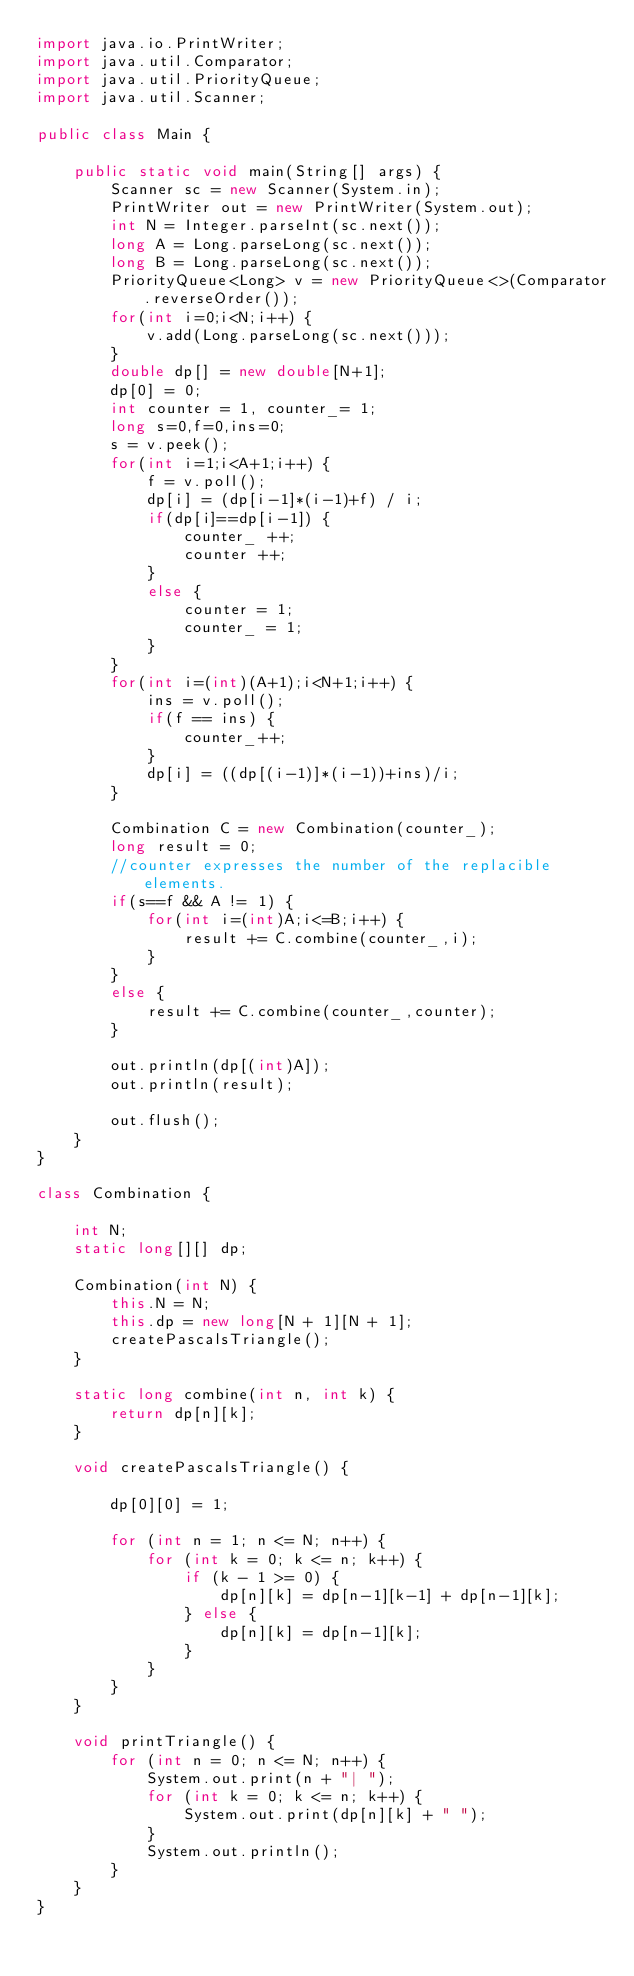<code> <loc_0><loc_0><loc_500><loc_500><_Java_>import java.io.PrintWriter;
import java.util.Comparator;
import java.util.PriorityQueue;
import java.util.Scanner;

public class Main {

	public static void main(String[] args) {
		Scanner sc = new Scanner(System.in);
		PrintWriter out = new PrintWriter(System.out);
		int N = Integer.parseInt(sc.next());
		long A = Long.parseLong(sc.next());
		long B = Long.parseLong(sc.next());
		PriorityQueue<Long> v = new PriorityQueue<>(Comparator.reverseOrder());
		for(int i=0;i<N;i++) {
			v.add(Long.parseLong(sc.next()));
		}
		double dp[] = new double[N+1];
		dp[0] = 0;
		int counter = 1, counter_= 1;
		long s=0,f=0,ins=0;
		s = v.peek();
		for(int i=1;i<A+1;i++) {
			f = v.poll();
			dp[i] = (dp[i-1]*(i-1)+f) / i;
			if(dp[i]==dp[i-1]) {
				counter_ ++;
				counter ++;
			}
			else {
				counter = 1;
				counter_ = 1;
			}
		}
		for(int i=(int)(A+1);i<N+1;i++) {
			ins = v.poll();
			if(f == ins) {
				counter_++;
			}
			dp[i] = ((dp[(i-1)]*(i-1))+ins)/i;
		}
		
		Combination C = new Combination(counter_);
		long result = 0;
		//counter expresses the number of the replacible elements.
		if(s==f && A != 1) {
			for(int i=(int)A;i<=B;i++) {
				result += C.combine(counter_,i);
			}
		}
		else {
			result += C.combine(counter_,counter);
		}

		out.println(dp[(int)A]);
		out.println(result);

		out.flush();
	}
}

class Combination {
	
	int N;
	static long[][] dp;
	
	Combination(int N) {
		this.N = N;
		this.dp = new long[N + 1][N + 1];
		createPascalsTriangle();
	}
	
	static long combine(int n, int k) {
		return dp[n][k];
	}
	
	void createPascalsTriangle() {
		
		dp[0][0] = 1;
		
		for (int n = 1; n <= N; n++) {
			for (int k = 0; k <= n; k++) {
				if (k - 1 >= 0) {
					dp[n][k] = dp[n-1][k-1] + dp[n-1][k];
				} else {
					dp[n][k] = dp[n-1][k];
				}
			}
		}
	}
	
	void printTriangle() {
		for (int n = 0; n <= N; n++) {
			System.out.print(n + "| ");
			for (int k = 0; k <= n; k++) {
				System.out.print(dp[n][k] + " ");
			}
			System.out.println();
		}
	}
}</code> 